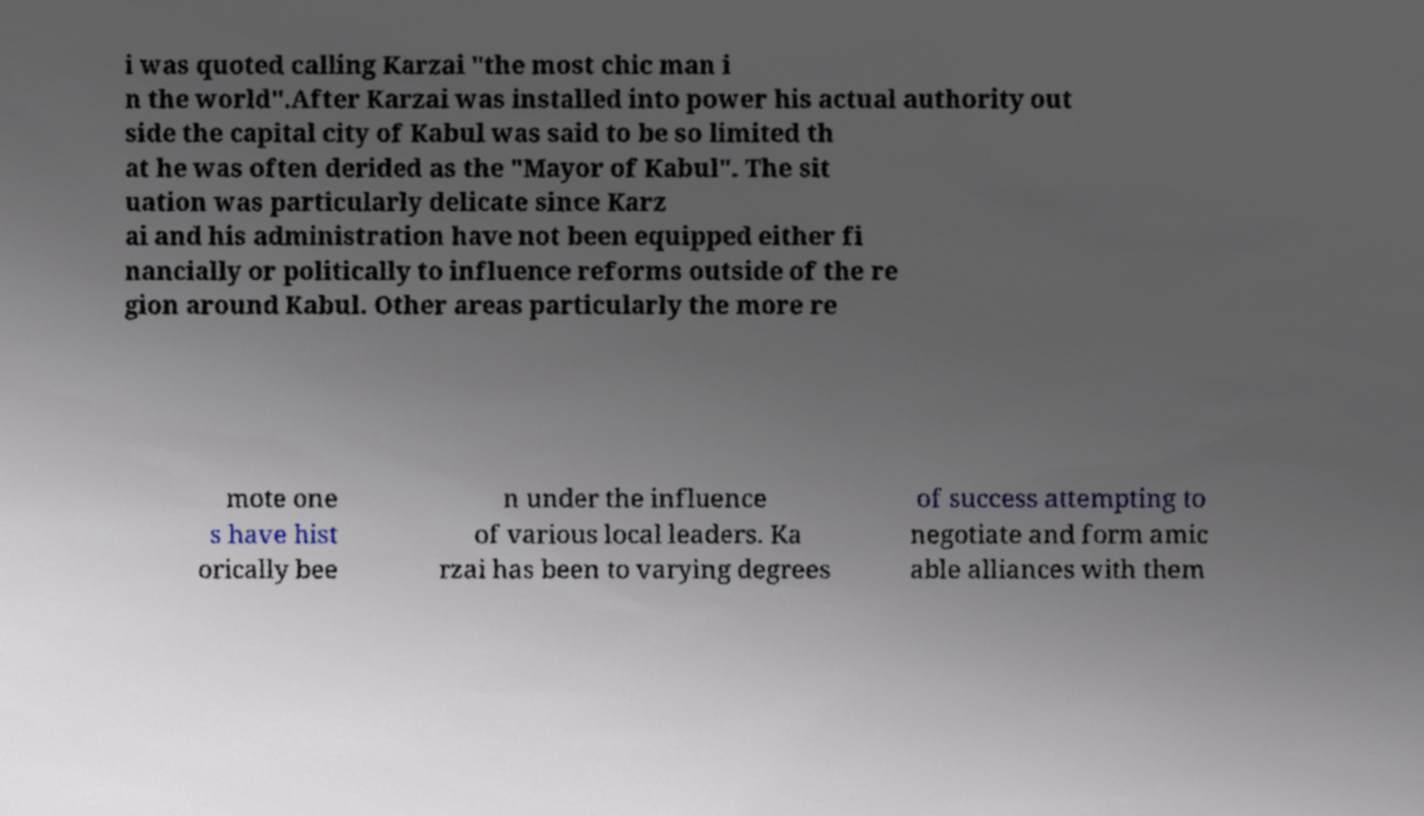Could you assist in decoding the text presented in this image and type it out clearly? i was quoted calling Karzai "the most chic man i n the world".After Karzai was installed into power his actual authority out side the capital city of Kabul was said to be so limited th at he was often derided as the "Mayor of Kabul". The sit uation was particularly delicate since Karz ai and his administration have not been equipped either fi nancially or politically to influence reforms outside of the re gion around Kabul. Other areas particularly the more re mote one s have hist orically bee n under the influence of various local leaders. Ka rzai has been to varying degrees of success attempting to negotiate and form amic able alliances with them 